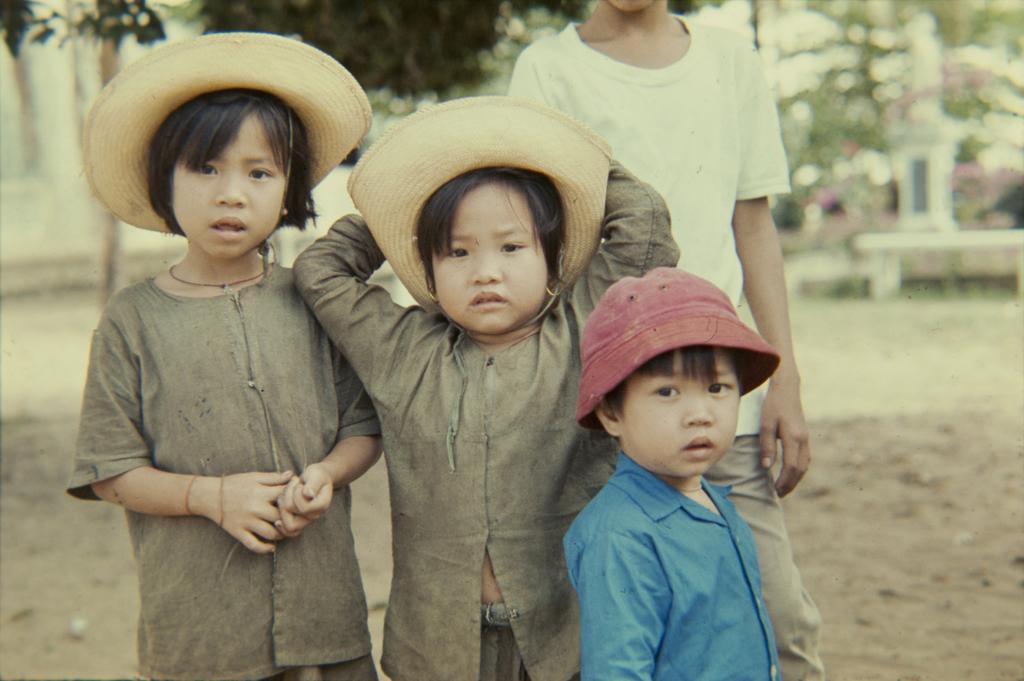Can you describe this image briefly? 3 Children are standing, these 2 children wore hats and this little boy wore cap. Behind them there are green color trees. 